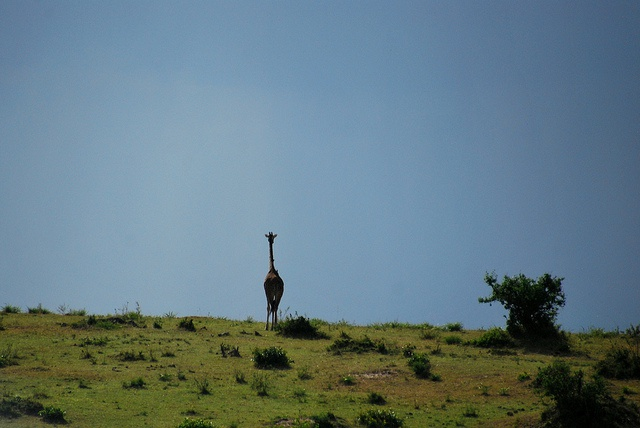Describe the objects in this image and their specific colors. I can see a giraffe in gray, black, and darkgray tones in this image. 